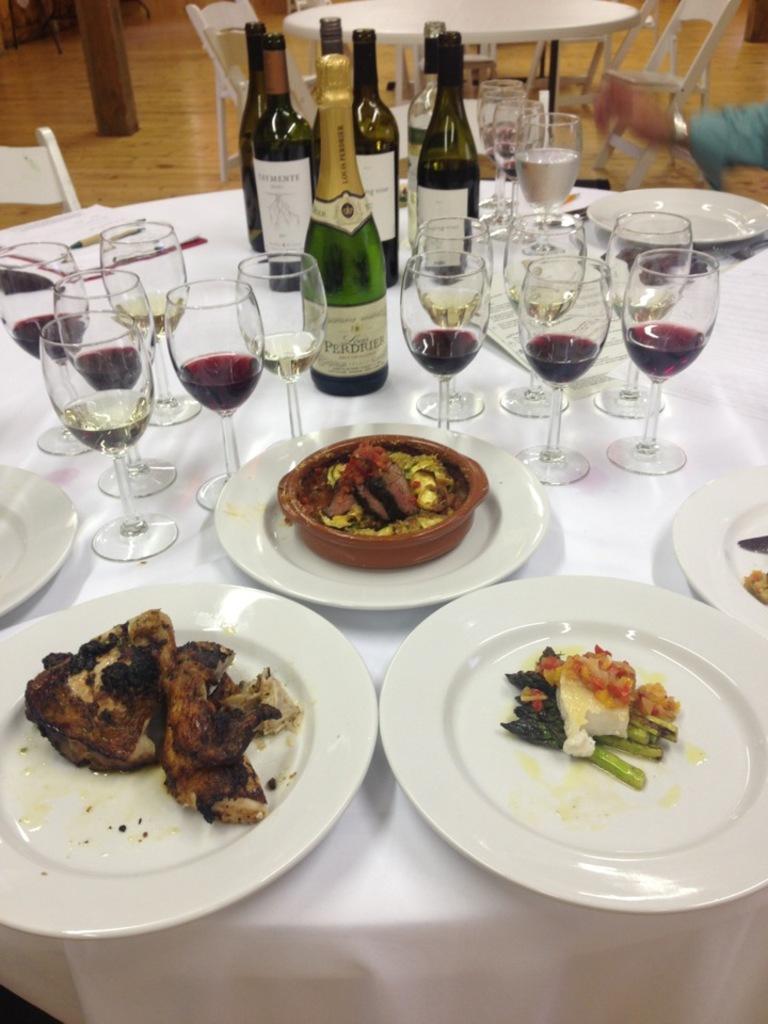Describe this image in one or two sentences. In this image we can see group of glasses, bottles and plates containing food is placed on the table. On the right side of the image we can see the hand of a person. At the top of the image we can see a table and some chairs placed on the floor. In the background, we can see pillars. 